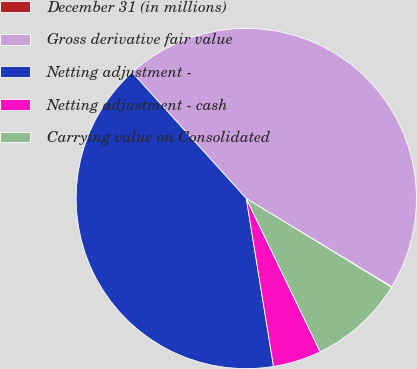Convert chart. <chart><loc_0><loc_0><loc_500><loc_500><pie_chart><fcel>December 31 (in millions)<fcel>Gross derivative fair value<fcel>Netting adjustment -<fcel>Netting adjustment - cash<fcel>Carrying value on Consolidated<nl><fcel>0.06%<fcel>45.38%<fcel>40.85%<fcel>4.59%<fcel>9.12%<nl></chart> 